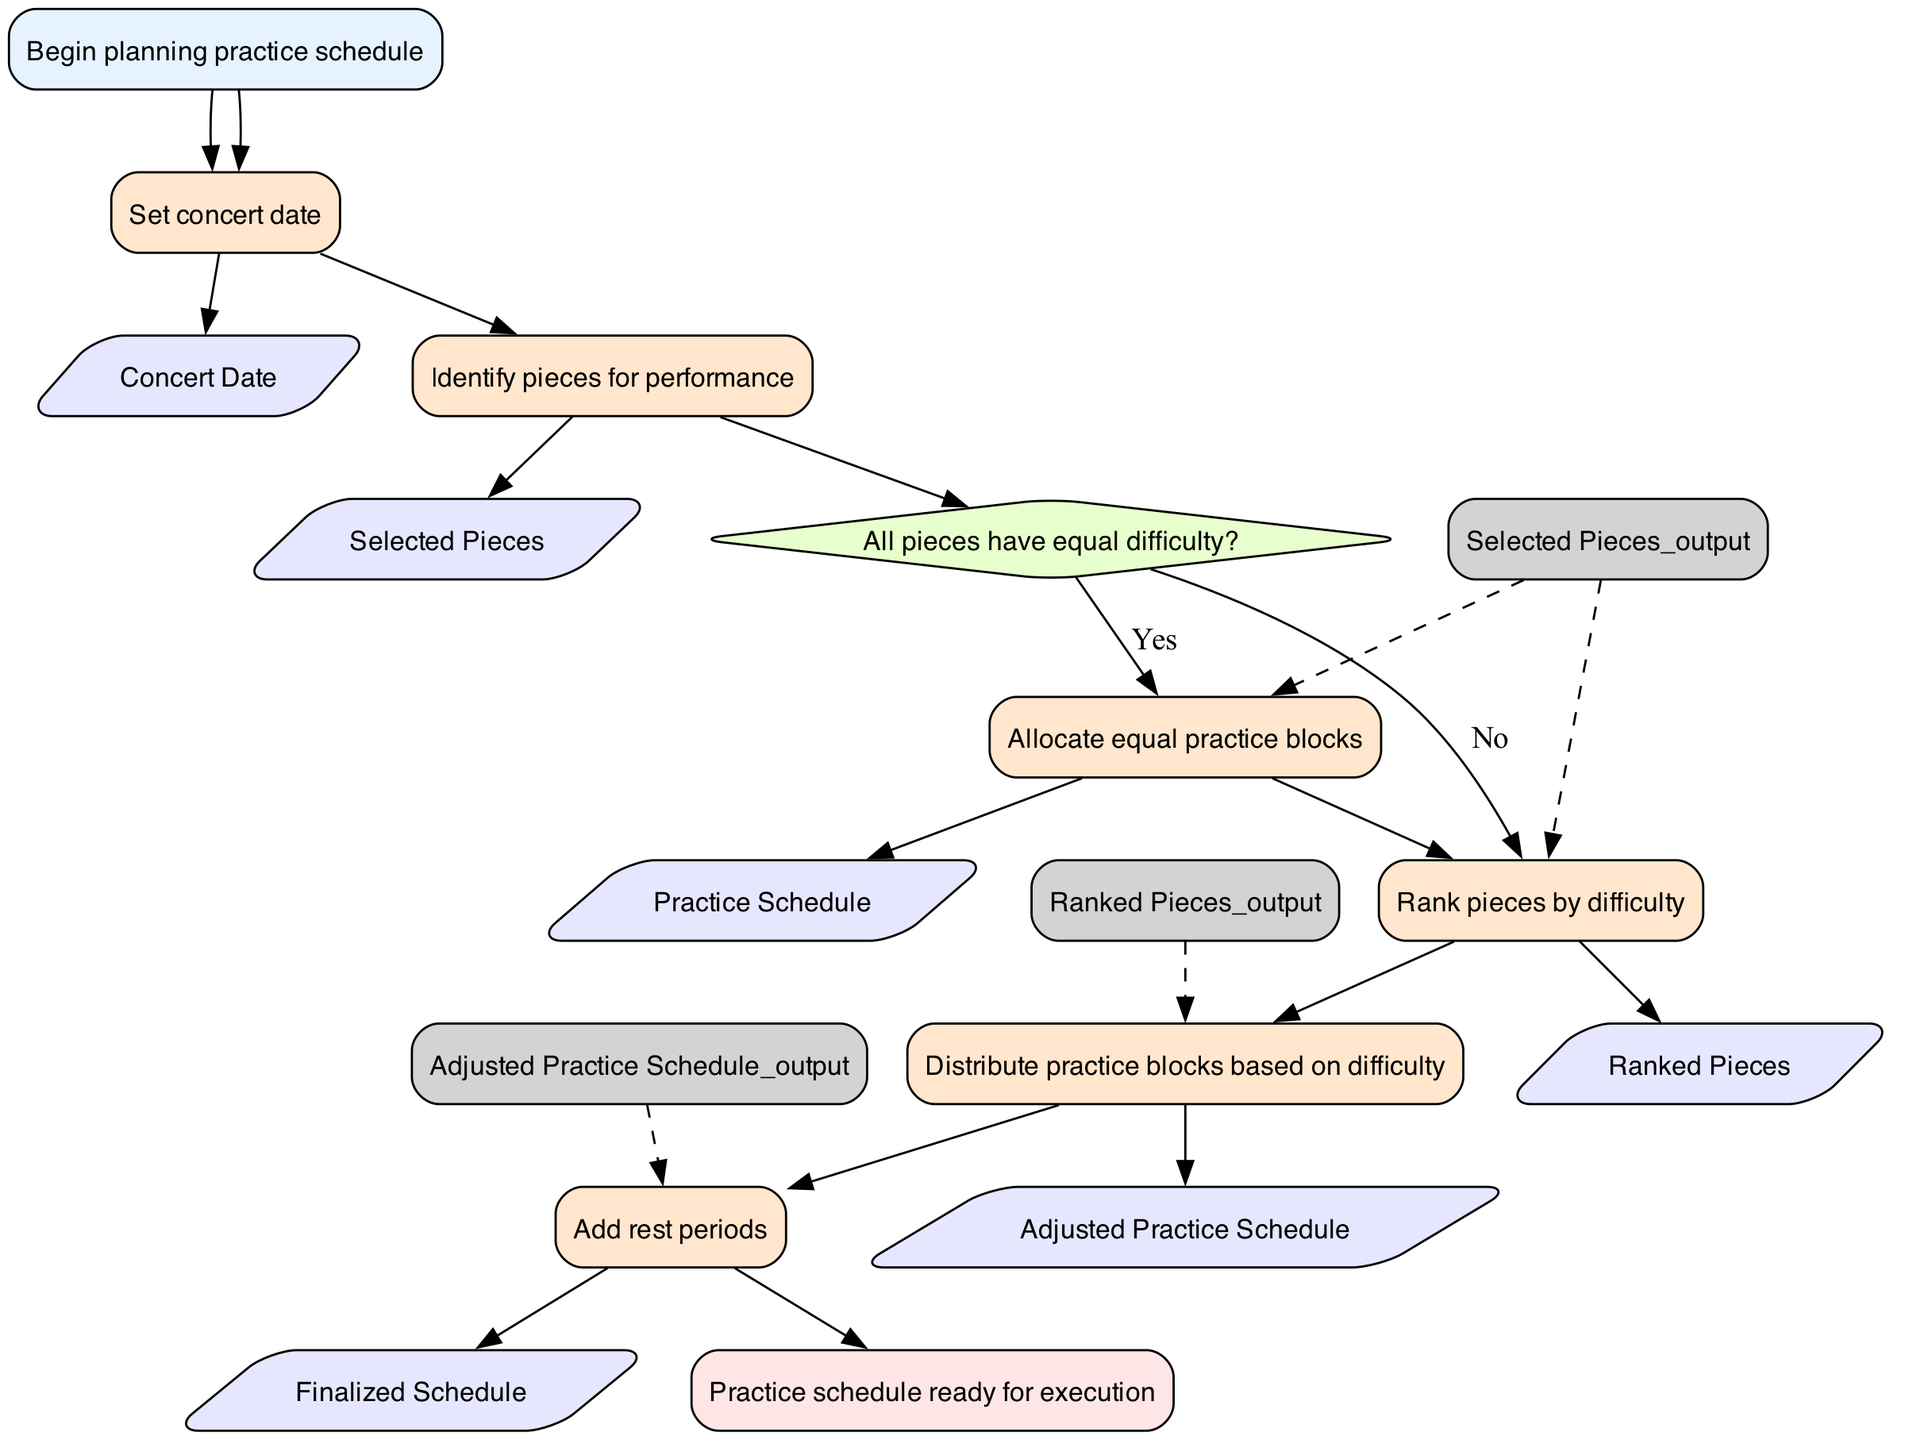What is the first step in the flowchart? The first step in the flowchart is labeled "Begin planning practice schedule," which signifies the start of the process.
Answer: Begin planning practice schedule How many total processes are in the diagram? By counting the number of nodes labeled as "Process," there are five processes in total: setting the concert date, identifying pieces, allocating practice blocks, distributing practice blocks based on difficulty, and adding rest periods.
Answer: Five What happens if all pieces have equal difficulty? If all pieces have equal difficulty, the flowchart indicates moving to step 4, where equal practice blocks are allocated to the selected pieces.
Answer: Allocate equal practice blocks What is the outcome of ranking pieces by difficulty? The outcome of ranking the pieces by difficulty is the "Ranked Pieces," which then allows for distributing practice blocks based on their respective difficulties in the next step of the process.
Answer: Ranked Pieces What is the final output of the flowchart? The final output of the flowchart, after completing all steps, is a "Practice schedule ready for execution," indicating that the schedule is fully prepared for practice.
Answer: Practice schedule ready for execution What type of block follows the decision block in the flowchart? Following the decision block, the flowchart transitions into a process block, specifically step 4 concerning the allocation of practice blocks.
Answer: Process block How many decision points are present in the flowchart? The flowchart contains one decision point, which determines whether all pieces have equal difficulty or not, influencing the subsequent steps in the process.
Answer: One What is the input for adding rest periods? The input for adding rest periods is the "Adjusted Practice Schedule," which is the outcome of distributing practice blocks based on the rankings of the pieces.
Answer: Adjusted Practice Schedule 